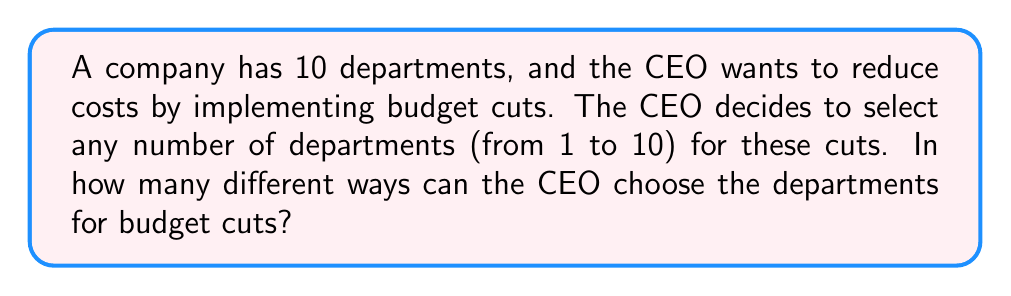Help me with this question. Let's approach this step-by-step:

1) This problem is about selecting subsets from a set of 10 departments. We need to count all possible subsets, excluding the empty set (as at least one department must be chosen).

2) The number of ways to select k items from n items is given by the combination formula:

   $${n \choose k} = \frac{n!}{k!(n-k)!}$$

3) We need to sum up all possible selections from 1 to 10 departments:

   $$\sum_{k=1}^{10} {10 \choose k}$$

4) This sum is equal to $2^n - 1$, where n is the total number of departments. This is because:
   
   $$\sum_{k=0}^{n} {n \choose k} = 2^n$$

   And we're excluding the case where k = 0 (no departments chosen).

5) Therefore, the number of ways to choose departments for budget cuts is:

   $$2^{10} - 1 = 1024 - 1 = 1023$$

This approach allows the CEO to consider all possible combinations of department selections for budget cuts, from choosing just one department to choosing all ten departments.
Answer: 1023 ways 